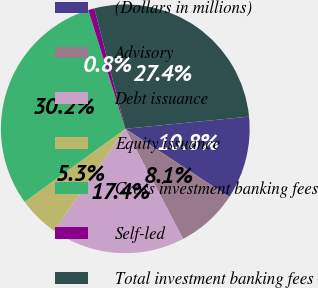Convert chart to OTSL. <chart><loc_0><loc_0><loc_500><loc_500><pie_chart><fcel>(Dollars in millions)<fcel>Advisory<fcel>Debt issuance<fcel>Equity issuance<fcel>Gross investment banking fees<fcel>Self-led<fcel>Total investment banking fees<nl><fcel>10.8%<fcel>8.06%<fcel>17.41%<fcel>5.31%<fcel>30.18%<fcel>0.8%<fcel>27.44%<nl></chart> 